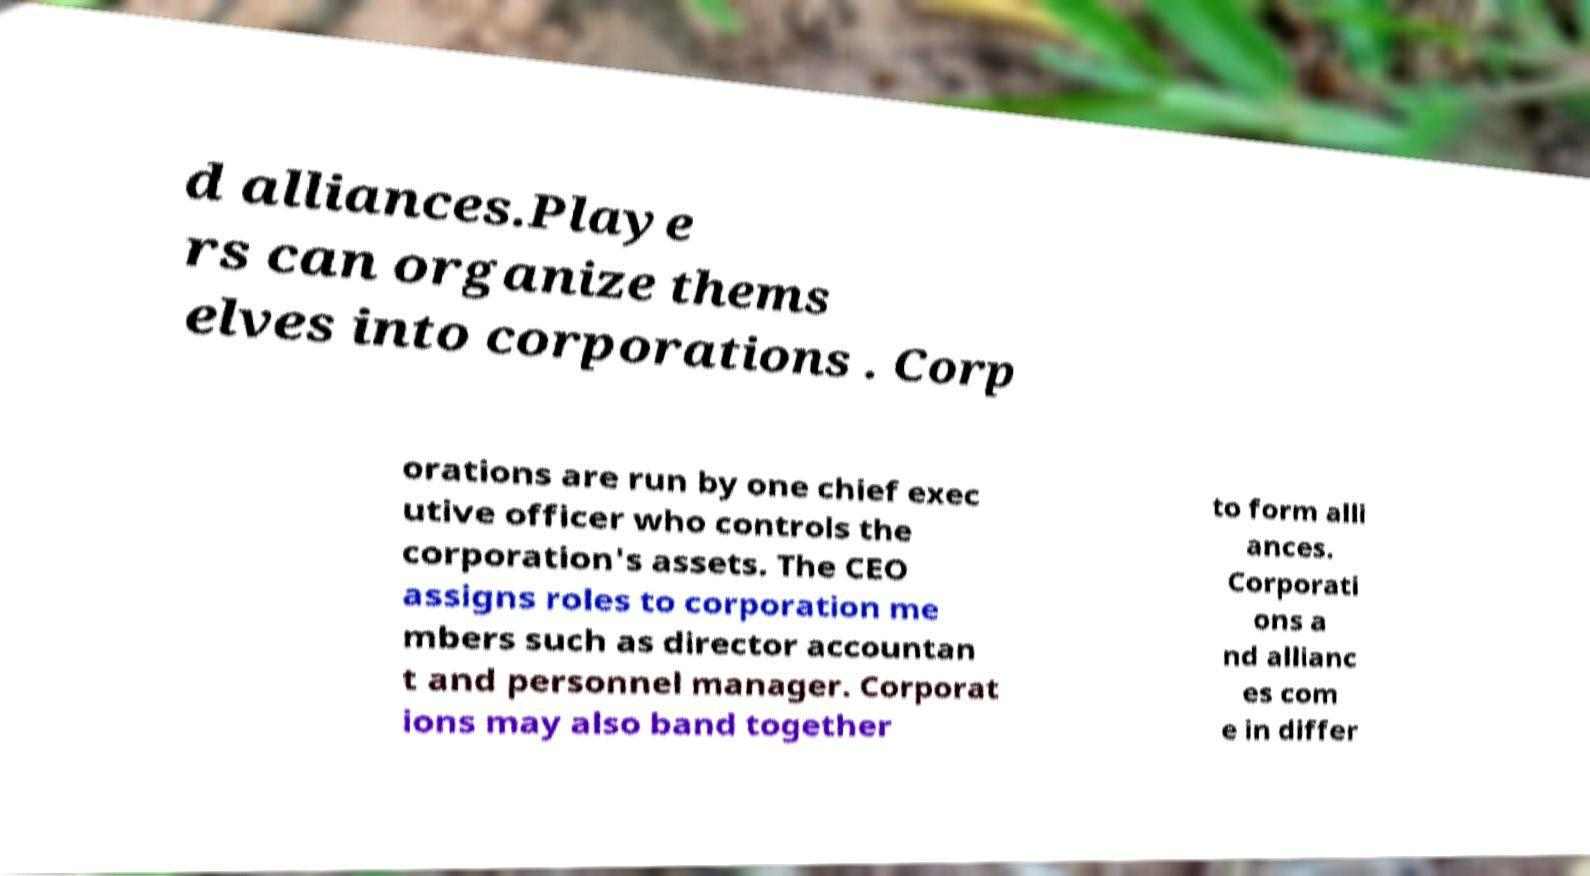There's text embedded in this image that I need extracted. Can you transcribe it verbatim? d alliances.Playe rs can organize thems elves into corporations . Corp orations are run by one chief exec utive officer who controls the corporation's assets. The CEO assigns roles to corporation me mbers such as director accountan t and personnel manager. Corporat ions may also band together to form alli ances. Corporati ons a nd allianc es com e in differ 